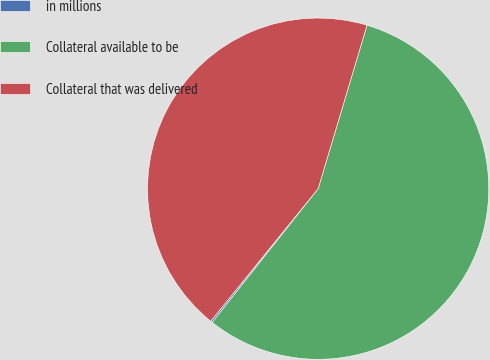Convert chart to OTSL. <chart><loc_0><loc_0><loc_500><loc_500><pie_chart><fcel>in millions<fcel>Collateral available to be<fcel>Collateral that was delivered<nl><fcel>0.18%<fcel>56.04%<fcel>43.78%<nl></chart> 